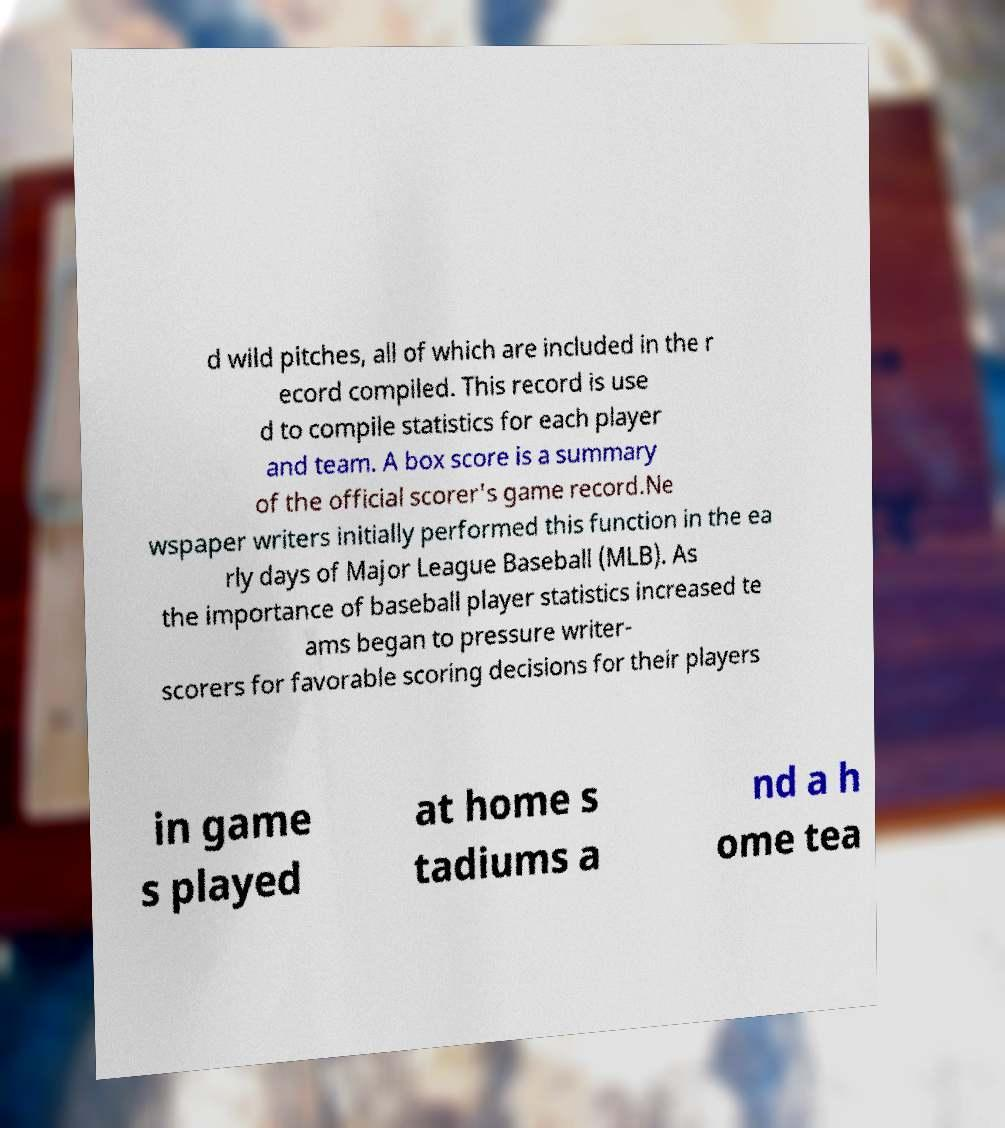There's text embedded in this image that I need extracted. Can you transcribe it verbatim? d wild pitches, all of which are included in the r ecord compiled. This record is use d to compile statistics for each player and team. A box score is a summary of the official scorer's game record.Ne wspaper writers initially performed this function in the ea rly days of Major League Baseball (MLB). As the importance of baseball player statistics increased te ams began to pressure writer- scorers for favorable scoring decisions for their players in game s played at home s tadiums a nd a h ome tea 